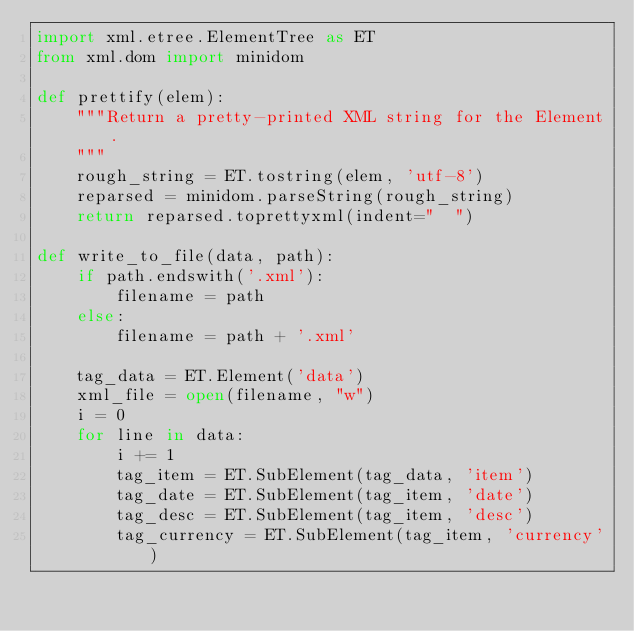<code> <loc_0><loc_0><loc_500><loc_500><_Python_>import xml.etree.ElementTree as ET
from xml.dom import minidom

def prettify(elem):
    """Return a pretty-printed XML string for the Element.
    """
    rough_string = ET.tostring(elem, 'utf-8')
    reparsed = minidom.parseString(rough_string)
    return reparsed.toprettyxml(indent="  ")

def write_to_file(data, path):
    if path.endswith('.xml'):
        filename = path
    else:
        filename = path + '.xml'

    tag_data = ET.Element('data')
    xml_file = open(filename, "w")
    i = 0
    for line in data:
        i += 1
        tag_item = ET.SubElement(tag_data, 'item')
        tag_date = ET.SubElement(tag_item, 'date')
        tag_desc = ET.SubElement(tag_item, 'desc')
        tag_currency = ET.SubElement(tag_item, 'currency')</code> 